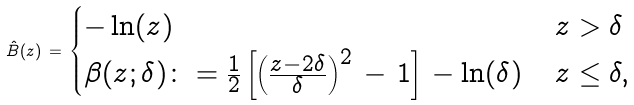<formula> <loc_0><loc_0><loc_500><loc_500>\hat { B } ( z ) \, = \, \begin{cases} - \ln ( z ) & \, z > \delta \\ \beta ( z ; \delta ) \colon = \frac { 1 } { 2 } \left [ \left ( \frac { z - 2 \delta } { \delta } \right ) ^ { 2 } \, - \, 1 \right ] \, - \ln ( \delta ) & \, z \leq \delta , \end{cases}</formula> 